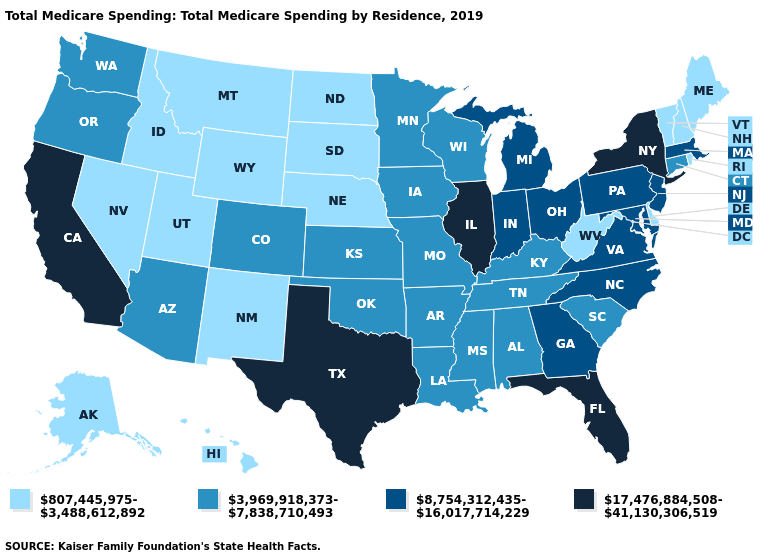Does North Dakota have the highest value in the USA?
Give a very brief answer. No. What is the value of Wisconsin?
Give a very brief answer. 3,969,918,373-7,838,710,493. Which states have the highest value in the USA?
Concise answer only. California, Florida, Illinois, New York, Texas. What is the value of Colorado?
Concise answer only. 3,969,918,373-7,838,710,493. What is the value of Washington?
Answer briefly. 3,969,918,373-7,838,710,493. What is the lowest value in the South?
Quick response, please. 807,445,975-3,488,612,892. Name the states that have a value in the range 8,754,312,435-16,017,714,229?
Concise answer only. Georgia, Indiana, Maryland, Massachusetts, Michigan, New Jersey, North Carolina, Ohio, Pennsylvania, Virginia. Name the states that have a value in the range 8,754,312,435-16,017,714,229?
Give a very brief answer. Georgia, Indiana, Maryland, Massachusetts, Michigan, New Jersey, North Carolina, Ohio, Pennsylvania, Virginia. Name the states that have a value in the range 17,476,884,508-41,130,306,519?
Short answer required. California, Florida, Illinois, New York, Texas. What is the value of New Hampshire?
Give a very brief answer. 807,445,975-3,488,612,892. Name the states that have a value in the range 807,445,975-3,488,612,892?
Concise answer only. Alaska, Delaware, Hawaii, Idaho, Maine, Montana, Nebraska, Nevada, New Hampshire, New Mexico, North Dakota, Rhode Island, South Dakota, Utah, Vermont, West Virginia, Wyoming. What is the value of Georgia?
Write a very short answer. 8,754,312,435-16,017,714,229. Does the first symbol in the legend represent the smallest category?
Keep it brief. Yes. Among the states that border Mississippi , which have the highest value?
Answer briefly. Alabama, Arkansas, Louisiana, Tennessee. Does Wyoming have the same value as South Dakota?
Answer briefly. Yes. 